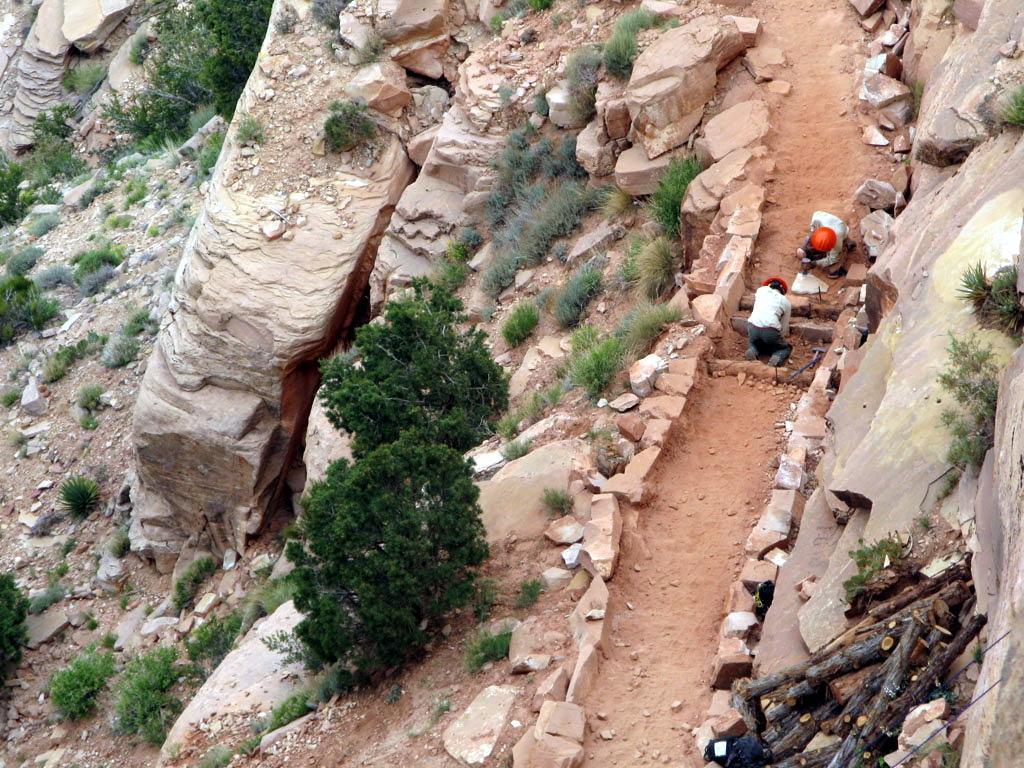How would you summarize this image in a sentence or two? In this picture we can see a few people wearing a helmet. We can see some grass, plants, a few wooden objects, stones and other objects on the ground. 